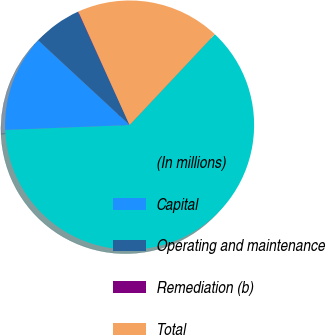Convert chart. <chart><loc_0><loc_0><loc_500><loc_500><pie_chart><fcel>(In millions)<fcel>Capital<fcel>Operating and maintenance<fcel>Remediation (b)<fcel>Total<nl><fcel>62.37%<fcel>12.52%<fcel>6.29%<fcel>0.06%<fcel>18.75%<nl></chart> 